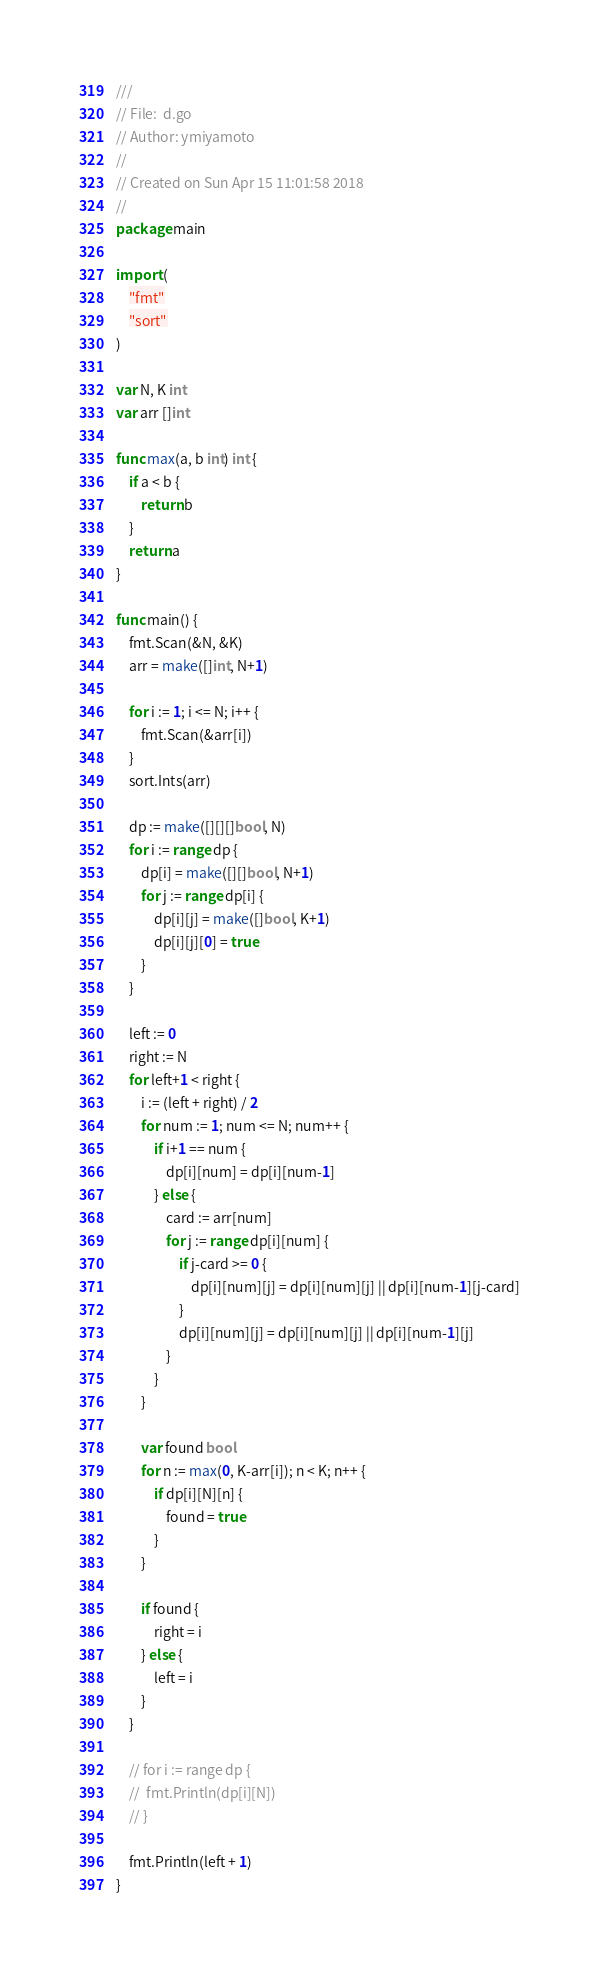Convert code to text. <code><loc_0><loc_0><loc_500><loc_500><_Go_>///
// File:  d.go
// Author: ymiyamoto
//
// Created on Sun Apr 15 11:01:58 2018
//
package main

import (
	"fmt"
	"sort"
)

var N, K int
var arr []int

func max(a, b int) int {
	if a < b {
		return b
	}
	return a
}

func main() {
	fmt.Scan(&N, &K)
	arr = make([]int, N+1)

	for i := 1; i <= N; i++ {
		fmt.Scan(&arr[i])
	}
	sort.Ints(arr)

	dp := make([][][]bool, N)
	for i := range dp {
		dp[i] = make([][]bool, N+1)
		for j := range dp[i] {
			dp[i][j] = make([]bool, K+1)
			dp[i][j][0] = true
		}
	}

	left := 0
	right := N
	for left+1 < right {
		i := (left + right) / 2
		for num := 1; num <= N; num++ {
			if i+1 == num {
				dp[i][num] = dp[i][num-1]
			} else {
				card := arr[num]
				for j := range dp[i][num] {
					if j-card >= 0 {
						dp[i][num][j] = dp[i][num][j] || dp[i][num-1][j-card]
					}
					dp[i][num][j] = dp[i][num][j] || dp[i][num-1][j]
				}
			}
		}

		var found bool
		for n := max(0, K-arr[i]); n < K; n++ {
			if dp[i][N][n] {
				found = true
			}
		}

		if found {
			right = i
		} else {
			left = i
		}
	}

	// for i := range dp {
	// 	fmt.Println(dp[i][N])
	// }

	fmt.Println(left + 1)
}
</code> 